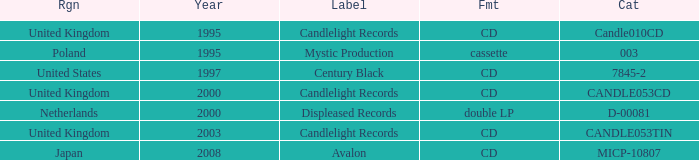What is Candlelight Records format? CD, CD, CD. 